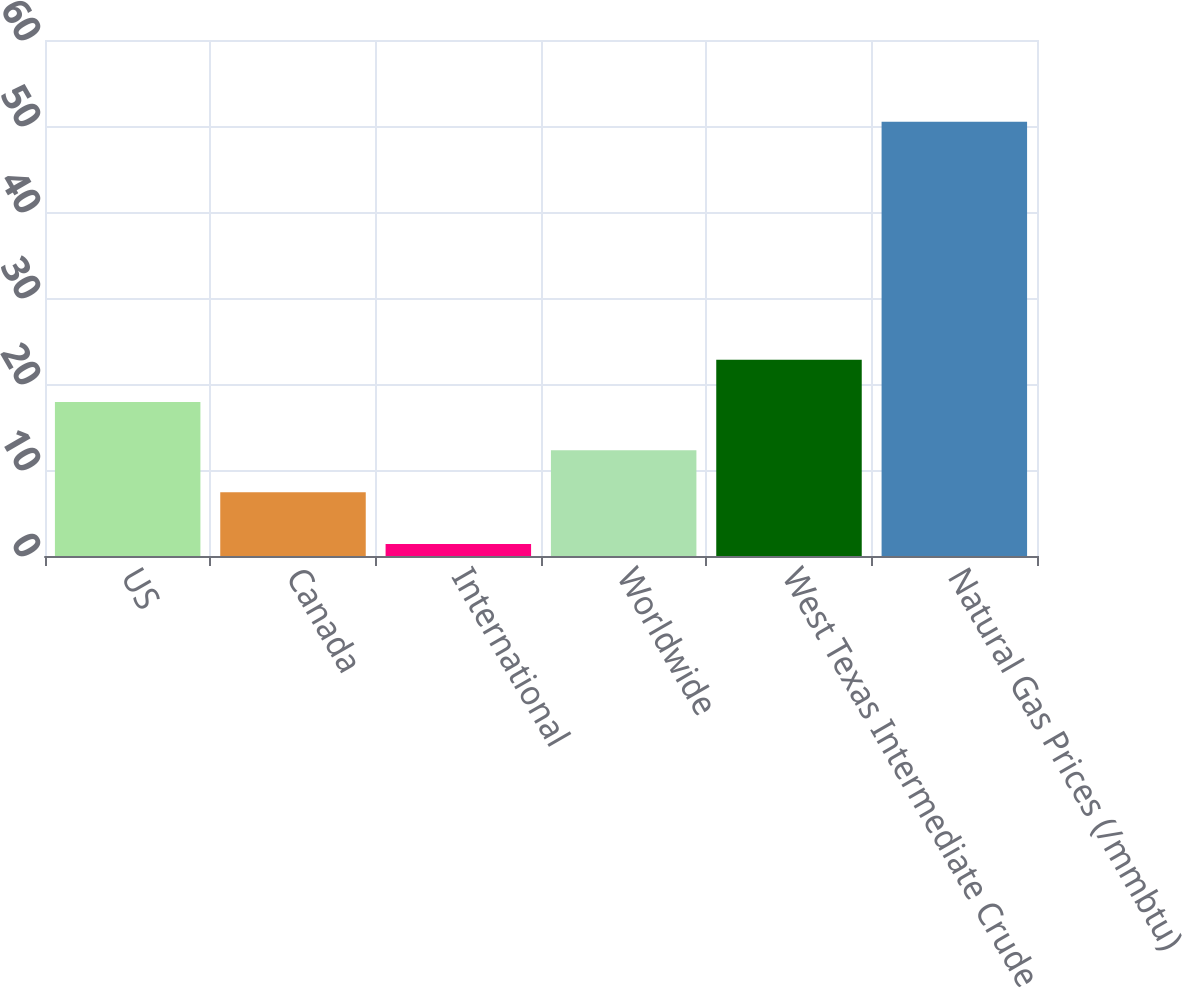Convert chart to OTSL. <chart><loc_0><loc_0><loc_500><loc_500><bar_chart><fcel>US<fcel>Canada<fcel>International<fcel>Worldwide<fcel>West Texas Intermediate Crude<fcel>Natural Gas Prices (/mmbtu)<nl><fcel>17.9<fcel>7.4<fcel>1.4<fcel>12.31<fcel>22.81<fcel>50.5<nl></chart> 